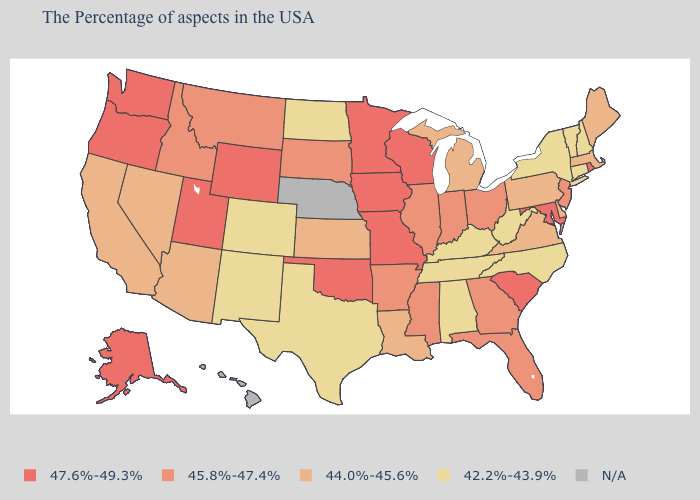What is the highest value in states that border Wisconsin?
Concise answer only. 47.6%-49.3%. What is the lowest value in the West?
Concise answer only. 42.2%-43.9%. Name the states that have a value in the range 42.2%-43.9%?
Be succinct. New Hampshire, Vermont, Connecticut, New York, North Carolina, West Virginia, Kentucky, Alabama, Tennessee, Texas, North Dakota, Colorado, New Mexico. What is the highest value in the USA?
Concise answer only. 47.6%-49.3%. Name the states that have a value in the range 44.0%-45.6%?
Be succinct. Maine, Massachusetts, Delaware, Pennsylvania, Virginia, Michigan, Louisiana, Kansas, Arizona, Nevada, California. Does Mississippi have the lowest value in the USA?
Be succinct. No. Does South Carolina have the highest value in the South?
Be succinct. Yes. Name the states that have a value in the range 44.0%-45.6%?
Write a very short answer. Maine, Massachusetts, Delaware, Pennsylvania, Virginia, Michigan, Louisiana, Kansas, Arizona, Nevada, California. Name the states that have a value in the range 45.8%-47.4%?
Keep it brief. New Jersey, Ohio, Florida, Georgia, Indiana, Illinois, Mississippi, Arkansas, South Dakota, Montana, Idaho. What is the value of Colorado?
Quick response, please. 42.2%-43.9%. Name the states that have a value in the range 45.8%-47.4%?
Write a very short answer. New Jersey, Ohio, Florida, Georgia, Indiana, Illinois, Mississippi, Arkansas, South Dakota, Montana, Idaho. Name the states that have a value in the range 47.6%-49.3%?
Give a very brief answer. Rhode Island, Maryland, South Carolina, Wisconsin, Missouri, Minnesota, Iowa, Oklahoma, Wyoming, Utah, Washington, Oregon, Alaska. What is the lowest value in the Northeast?
Be succinct. 42.2%-43.9%. Does New York have the highest value in the Northeast?
Concise answer only. No. Name the states that have a value in the range 42.2%-43.9%?
Write a very short answer. New Hampshire, Vermont, Connecticut, New York, North Carolina, West Virginia, Kentucky, Alabama, Tennessee, Texas, North Dakota, Colorado, New Mexico. 